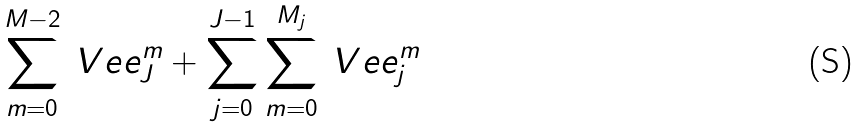<formula> <loc_0><loc_0><loc_500><loc_500>\sum _ { m = 0 } ^ { M - 2 } \ V e e ^ { m } _ { J } + \sum _ { j = 0 } ^ { J - 1 } \sum _ { m = 0 } ^ { M _ { j } } \ V e e ^ { m } _ { j }</formula> 